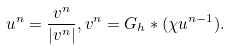<formula> <loc_0><loc_0><loc_500><loc_500>u ^ { n } = \frac { v ^ { n } } { | v ^ { n } | } , v ^ { n } = G _ { h } \ast ( \chi u ^ { n - 1 } ) .</formula> 